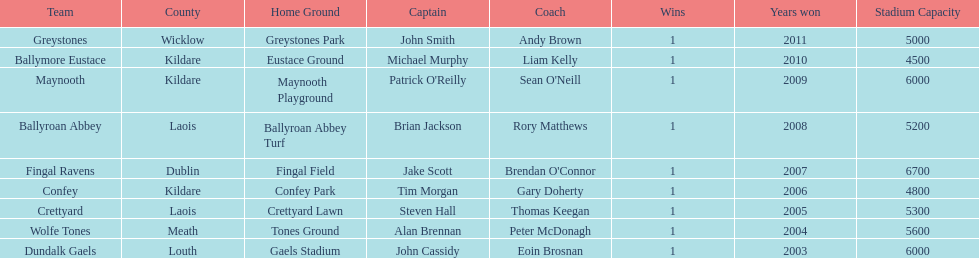What is the number of wins for confey 1. 